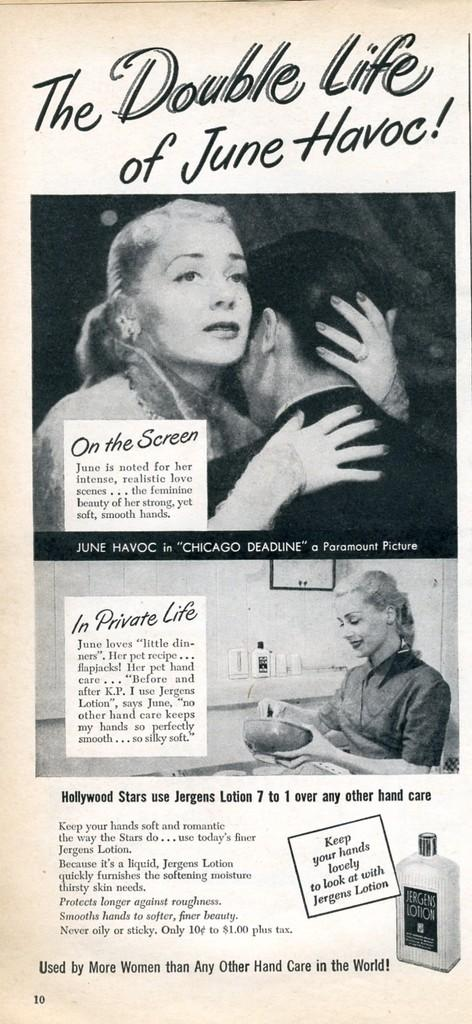What is present in the image that contains both images and text? There is a poster in the image that contains images and text. What type of pie is being served on the poster in the image? There is no pie present on the poster in the image. How many mittens are depicted on the poster in the image? There are no mittens depicted on the poster in the image. 